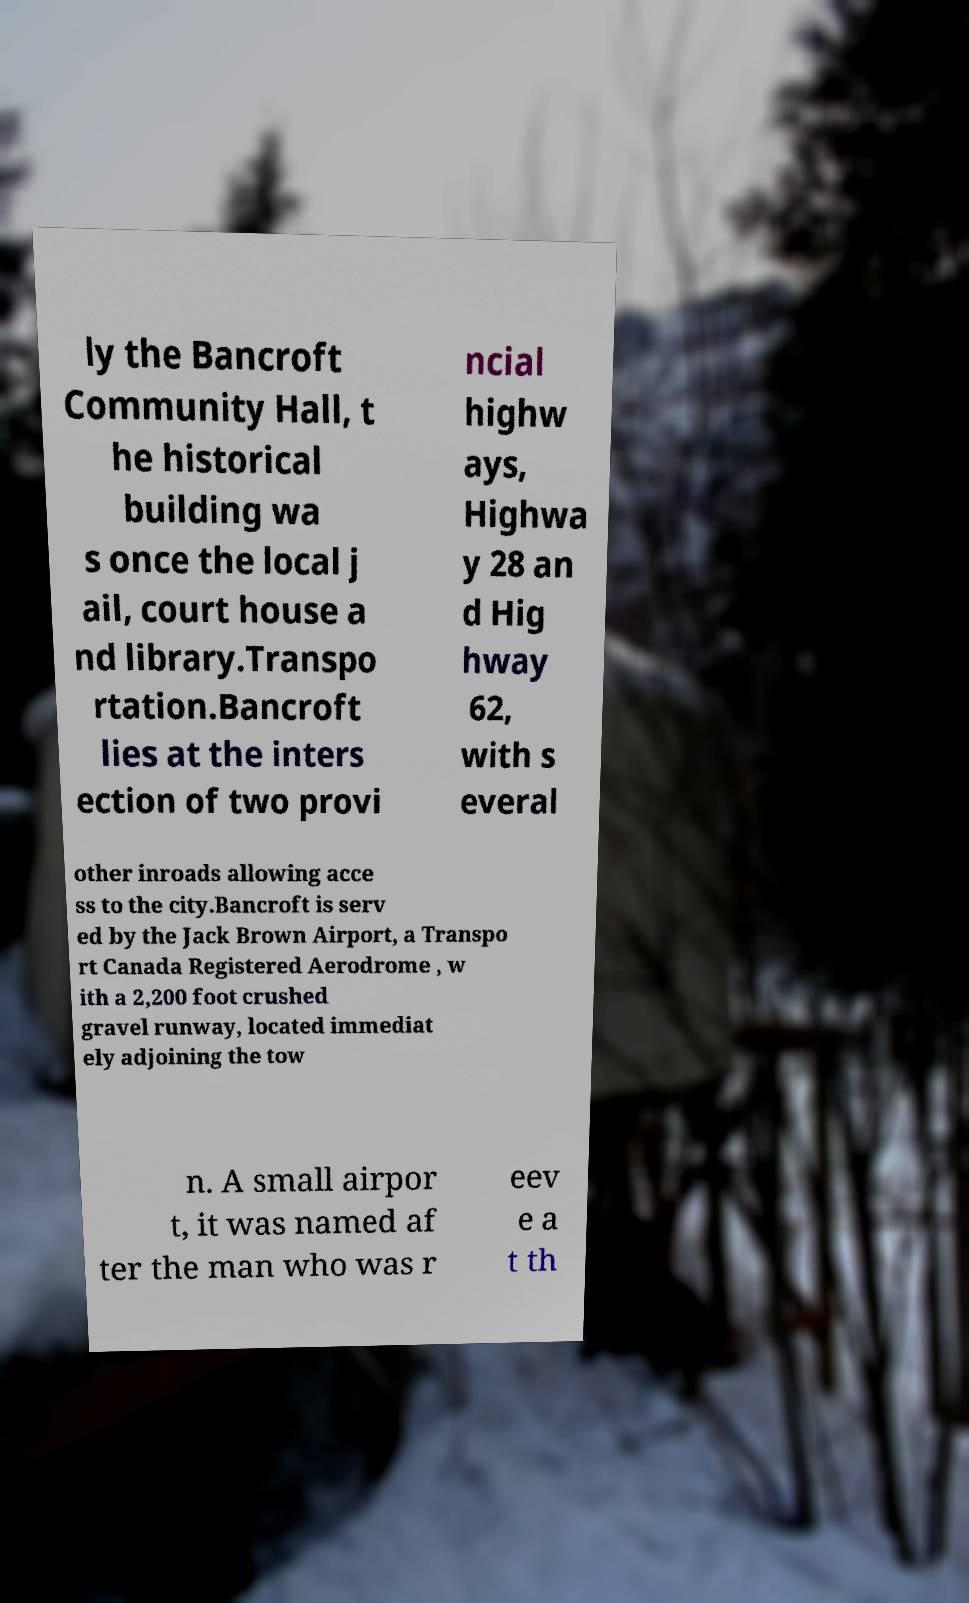Can you read and provide the text displayed in the image?This photo seems to have some interesting text. Can you extract and type it out for me? ly the Bancroft Community Hall, t he historical building wa s once the local j ail, court house a nd library.Transpo rtation.Bancroft lies at the inters ection of two provi ncial highw ays, Highwa y 28 an d Hig hway 62, with s everal other inroads allowing acce ss to the city.Bancroft is serv ed by the Jack Brown Airport, a Transpo rt Canada Registered Aerodrome , w ith a 2,200 foot crushed gravel runway, located immediat ely adjoining the tow n. A small airpor t, it was named af ter the man who was r eev e a t th 